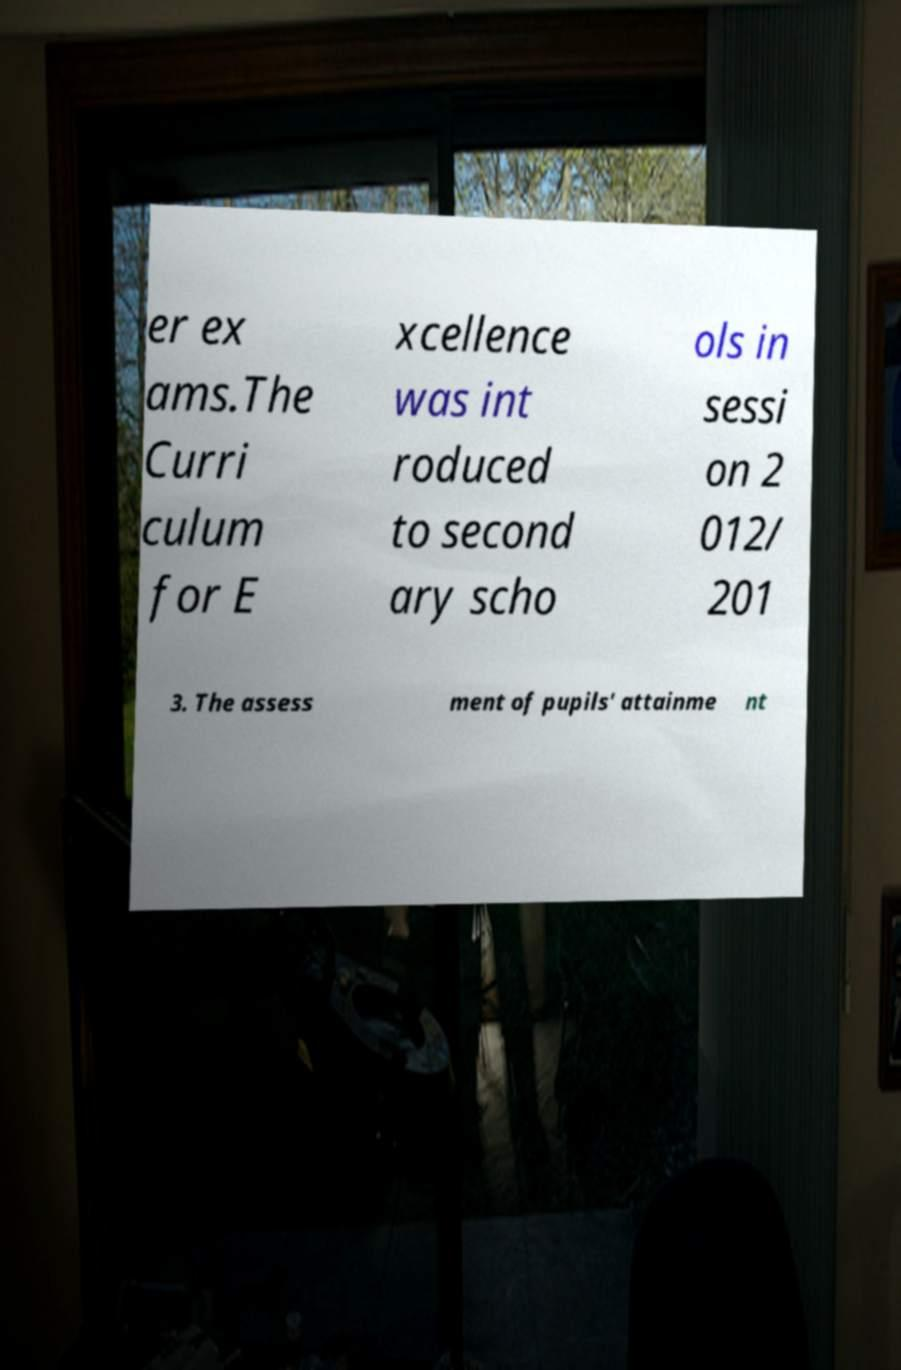Can you read and provide the text displayed in the image?This photo seems to have some interesting text. Can you extract and type it out for me? er ex ams.The Curri culum for E xcellence was int roduced to second ary scho ols in sessi on 2 012/ 201 3. The assess ment of pupils' attainme nt 